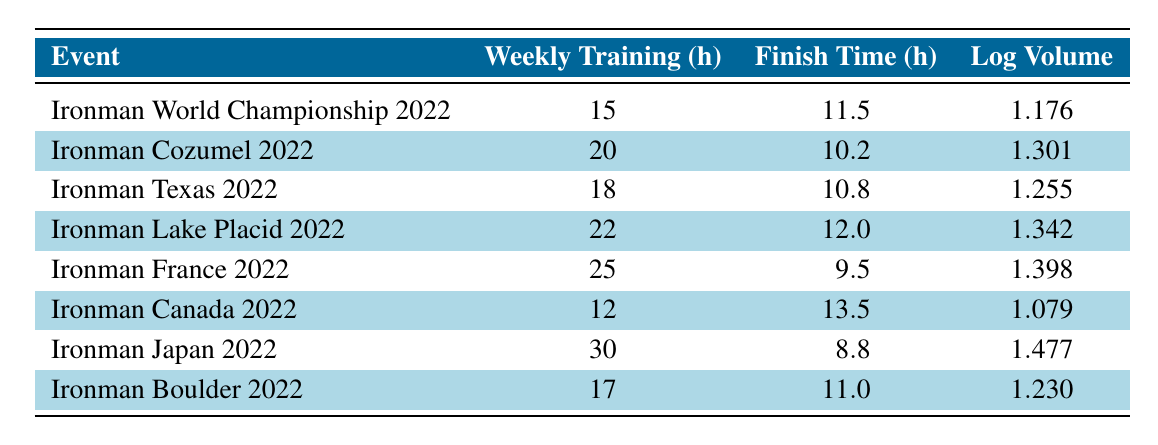What was the finish time for Ironman Japan 2022? The finish time for Ironman Japan 2022 is listed directly in the table as 8.8 hours.
Answer: 8.8 What is the weekly training volume for Ironman France 2022? The weekly training volume for Ironman France 2022 is given in the table as 25 hours.
Answer: 25 Which event had the longest finish time? By comparing the finish times listed in the table, Ironman Canada 2022 has the longest finish time of 13.5 hours.
Answer: 13.5 What is the difference in finish time between Ironman Cozumel 2022 and Ironman France 2022? Ironman Cozumel 2022 has a finish time of 10.2 hours, while Ironman France 2022 has 9.5 hours. The difference is calculated as 10.2 - 9.5 = 0.7 hours.
Answer: 0.7 Is it true that a higher weekly training volume leads to lower finish times based on this data? To determine this, we can compare the weekly training volume to finish times. The table shows that as weekly training volume increases (from 12 hours to 30 hours), the finish times vary, with both high and low finish times present at different training volumes. Thus, the relationship is not definitive based on this data.
Answer: No What is the average weekly training volume across all events? To find the average, we sum the weekly training volumes (15 + 20 + 18 + 22 + 25 + 12 + 30 + 17) = 149 hours and divide by the number of events (8), giving us 149/8 = 18.625 hours.
Answer: 18.625 What is the largest logarithmic volume value recorded in this table? The logarithmic volume values need to be reviewed to find the largest one. Upon reviewing the values, Ironman Japan 2022 has the maximum value of 1.477.
Answer: 1.477 Did any event have a finish time of less than 10 hours? We can check the finish times listed in the table. Ironman Japan 2022 has a finish time of 8.8 hours, which is less than 10 hours, confirming that this statement is true.
Answer: Yes Which event achieved the fastest finish time without training more than 20 hours per week? Reviewing the table, Ironman Cozumel 2022 has a finish time of 10.2 hours and a training volume of 20 hours. Ironman Texas 2022 also meets the criteria with a finish time of 10.8 hours. However, the fastest among these is Ironman Cozumel 2022.
Answer: Ironman Cozumel 2022 